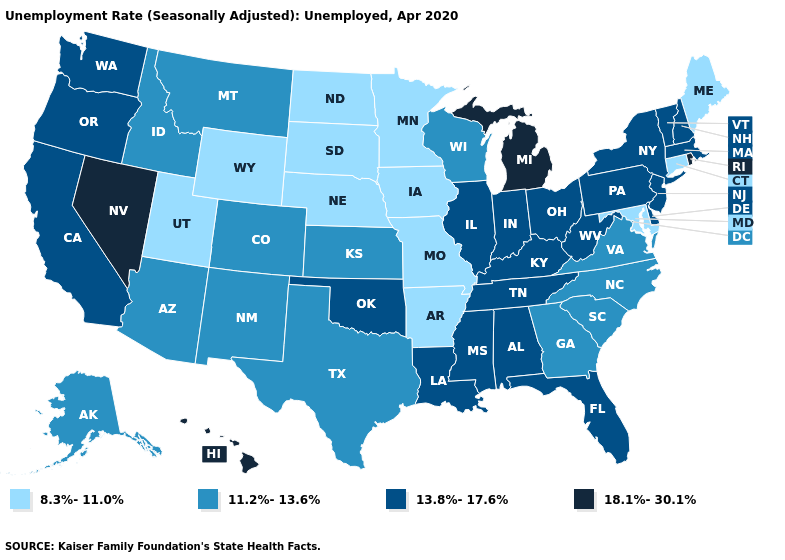Among the states that border South Dakota , which have the highest value?
Write a very short answer. Montana. What is the highest value in the USA?
Give a very brief answer. 18.1%-30.1%. How many symbols are there in the legend?
Concise answer only. 4. What is the lowest value in the USA?
Concise answer only. 8.3%-11.0%. Does Louisiana have the highest value in the USA?
Quick response, please. No. Name the states that have a value in the range 8.3%-11.0%?
Be succinct. Arkansas, Connecticut, Iowa, Maine, Maryland, Minnesota, Missouri, Nebraska, North Dakota, South Dakota, Utah, Wyoming. What is the value of Virginia?
Short answer required. 11.2%-13.6%. Does the map have missing data?
Be succinct. No. Among the states that border Maryland , does West Virginia have the highest value?
Be succinct. Yes. What is the highest value in the West ?
Concise answer only. 18.1%-30.1%. Which states have the lowest value in the USA?
Quick response, please. Arkansas, Connecticut, Iowa, Maine, Maryland, Minnesota, Missouri, Nebraska, North Dakota, South Dakota, Utah, Wyoming. Name the states that have a value in the range 13.8%-17.6%?
Answer briefly. Alabama, California, Delaware, Florida, Illinois, Indiana, Kentucky, Louisiana, Massachusetts, Mississippi, New Hampshire, New Jersey, New York, Ohio, Oklahoma, Oregon, Pennsylvania, Tennessee, Vermont, Washington, West Virginia. Which states hav the highest value in the Northeast?
Write a very short answer. Rhode Island. What is the value of Wyoming?
Give a very brief answer. 8.3%-11.0%. Does Vermont have the same value as Delaware?
Give a very brief answer. Yes. 